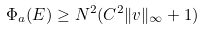<formula> <loc_0><loc_0><loc_500><loc_500>\Phi _ { \L a } ( E ) \geq N ^ { 2 } ( C ^ { 2 } \| v \| _ { \infty } + 1 )</formula> 